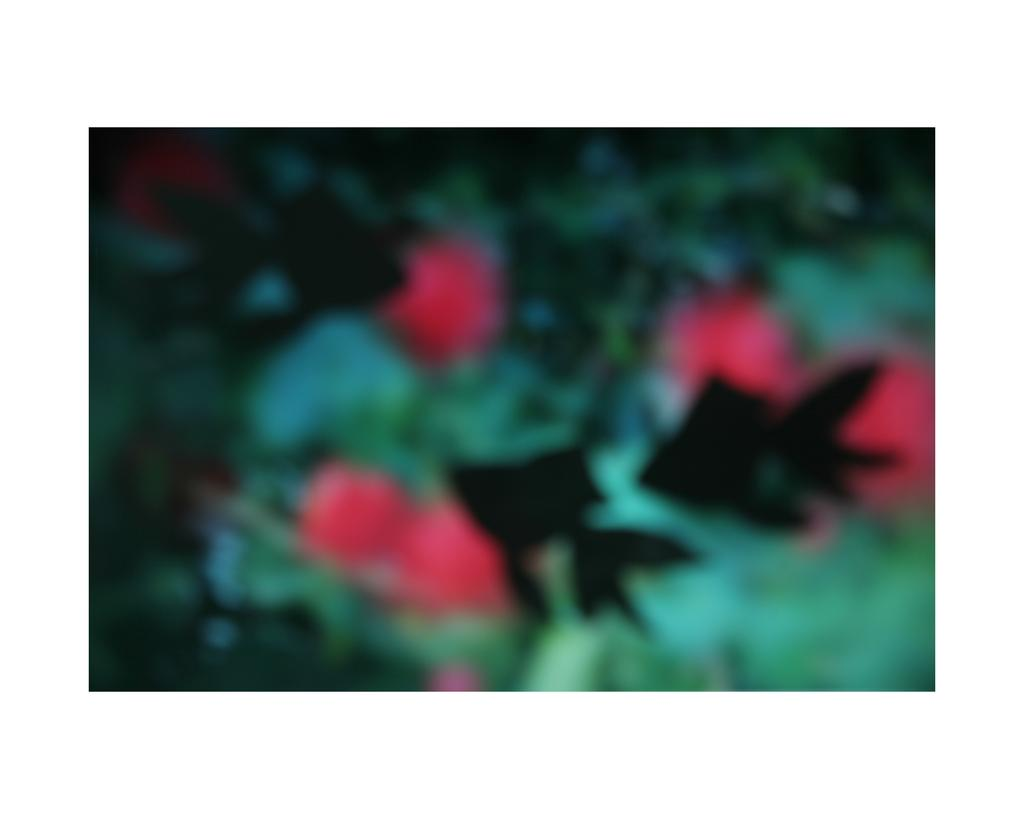What is the overall quality of the image? The image is blurry. What type of natural elements can be seen in the image? There are leaves visible in the image. What color stands out in the image? There are red color objects in the image. What type of slope can be seen in the image? There is no slope present in the image; it only contains leaves and red color objects. How does the soap affect the image? There is no soap present in the image, so it cannot affect the image. 